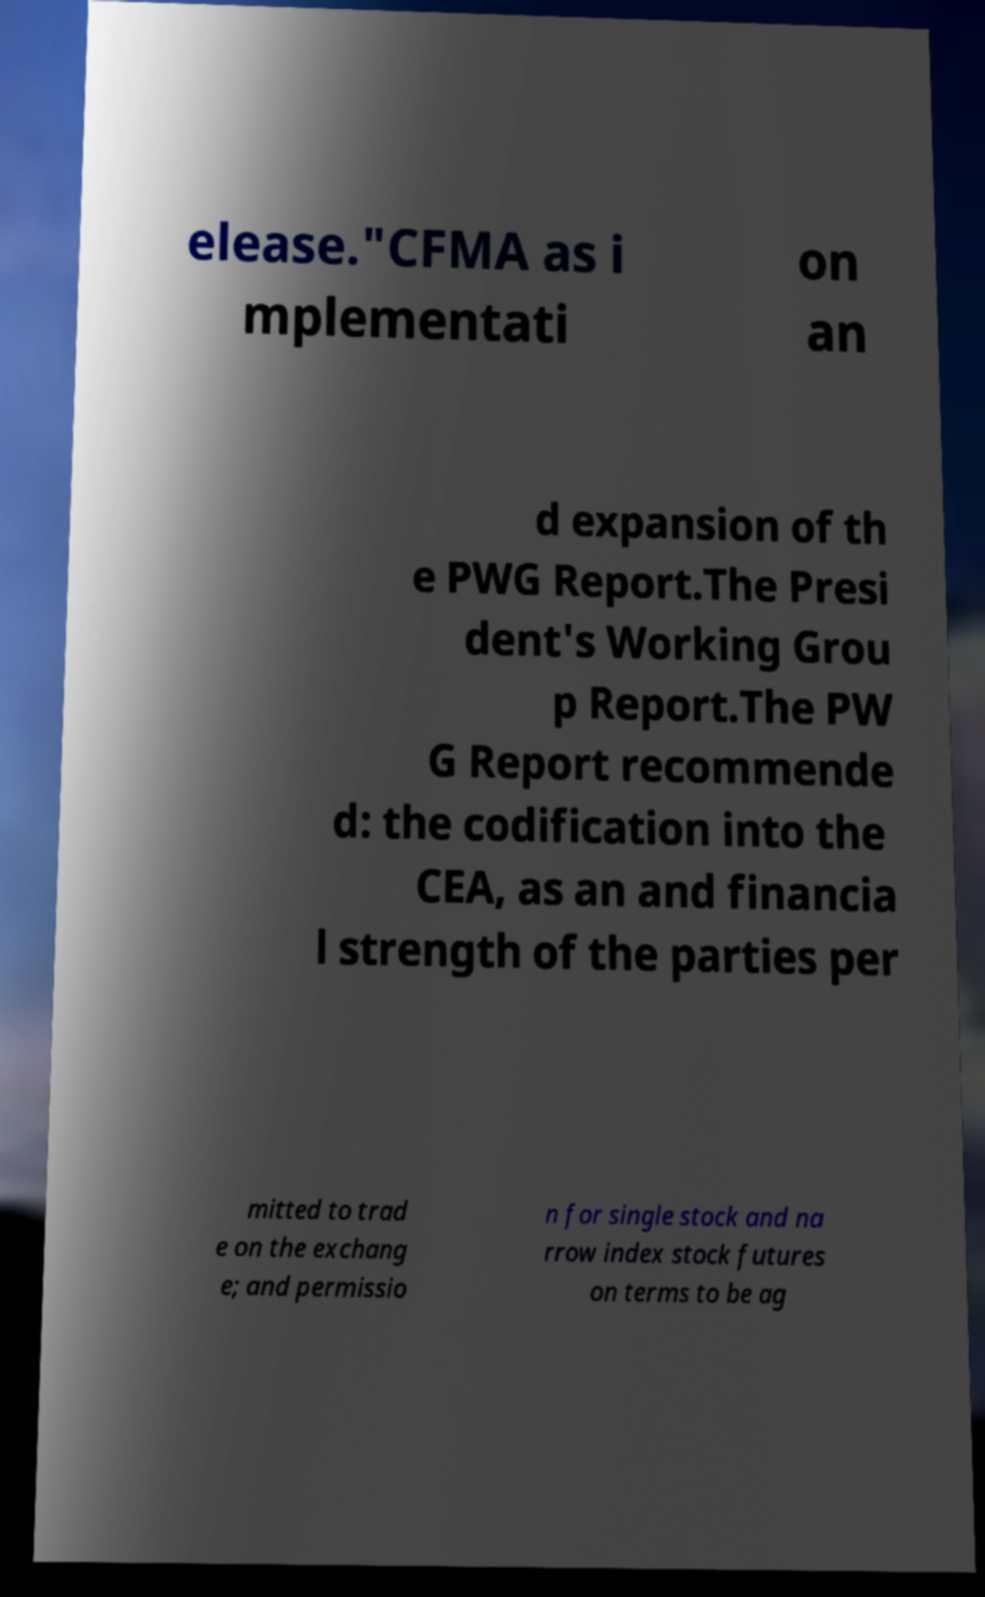Please read and relay the text visible in this image. What does it say? elease."CFMA as i mplementati on an d expansion of th e PWG Report.The Presi dent's Working Grou p Report.The PW G Report recommende d: the codification into the CEA, as an and financia l strength of the parties per mitted to trad e on the exchang e; and permissio n for single stock and na rrow index stock futures on terms to be ag 